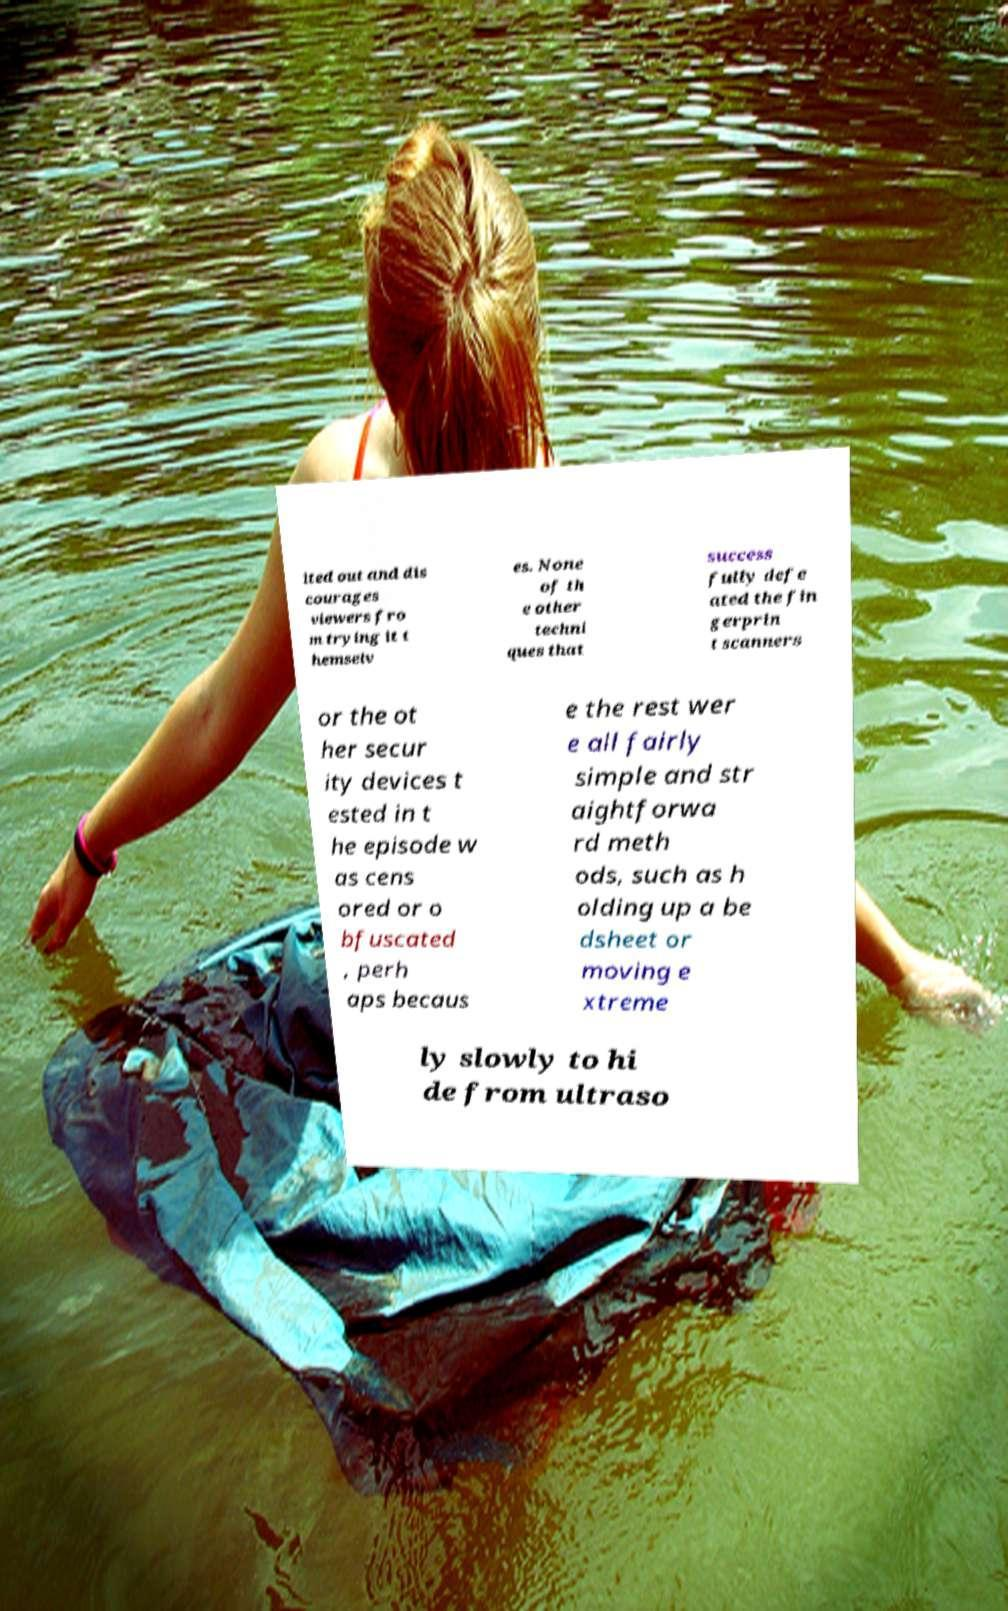Please read and relay the text visible in this image. What does it say? ited out and dis courages viewers fro m trying it t hemselv es. None of th e other techni ques that success fully defe ated the fin gerprin t scanners or the ot her secur ity devices t ested in t he episode w as cens ored or o bfuscated , perh aps becaus e the rest wer e all fairly simple and str aightforwa rd meth ods, such as h olding up a be dsheet or moving e xtreme ly slowly to hi de from ultraso 